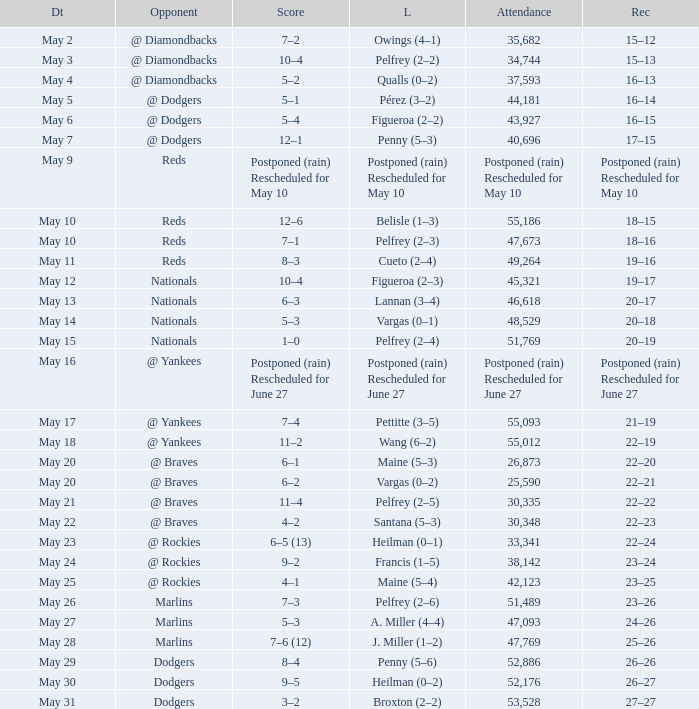Loss of postponed (rain) rescheduled for may 10 had what record? Postponed (rain) Rescheduled for May 10. 